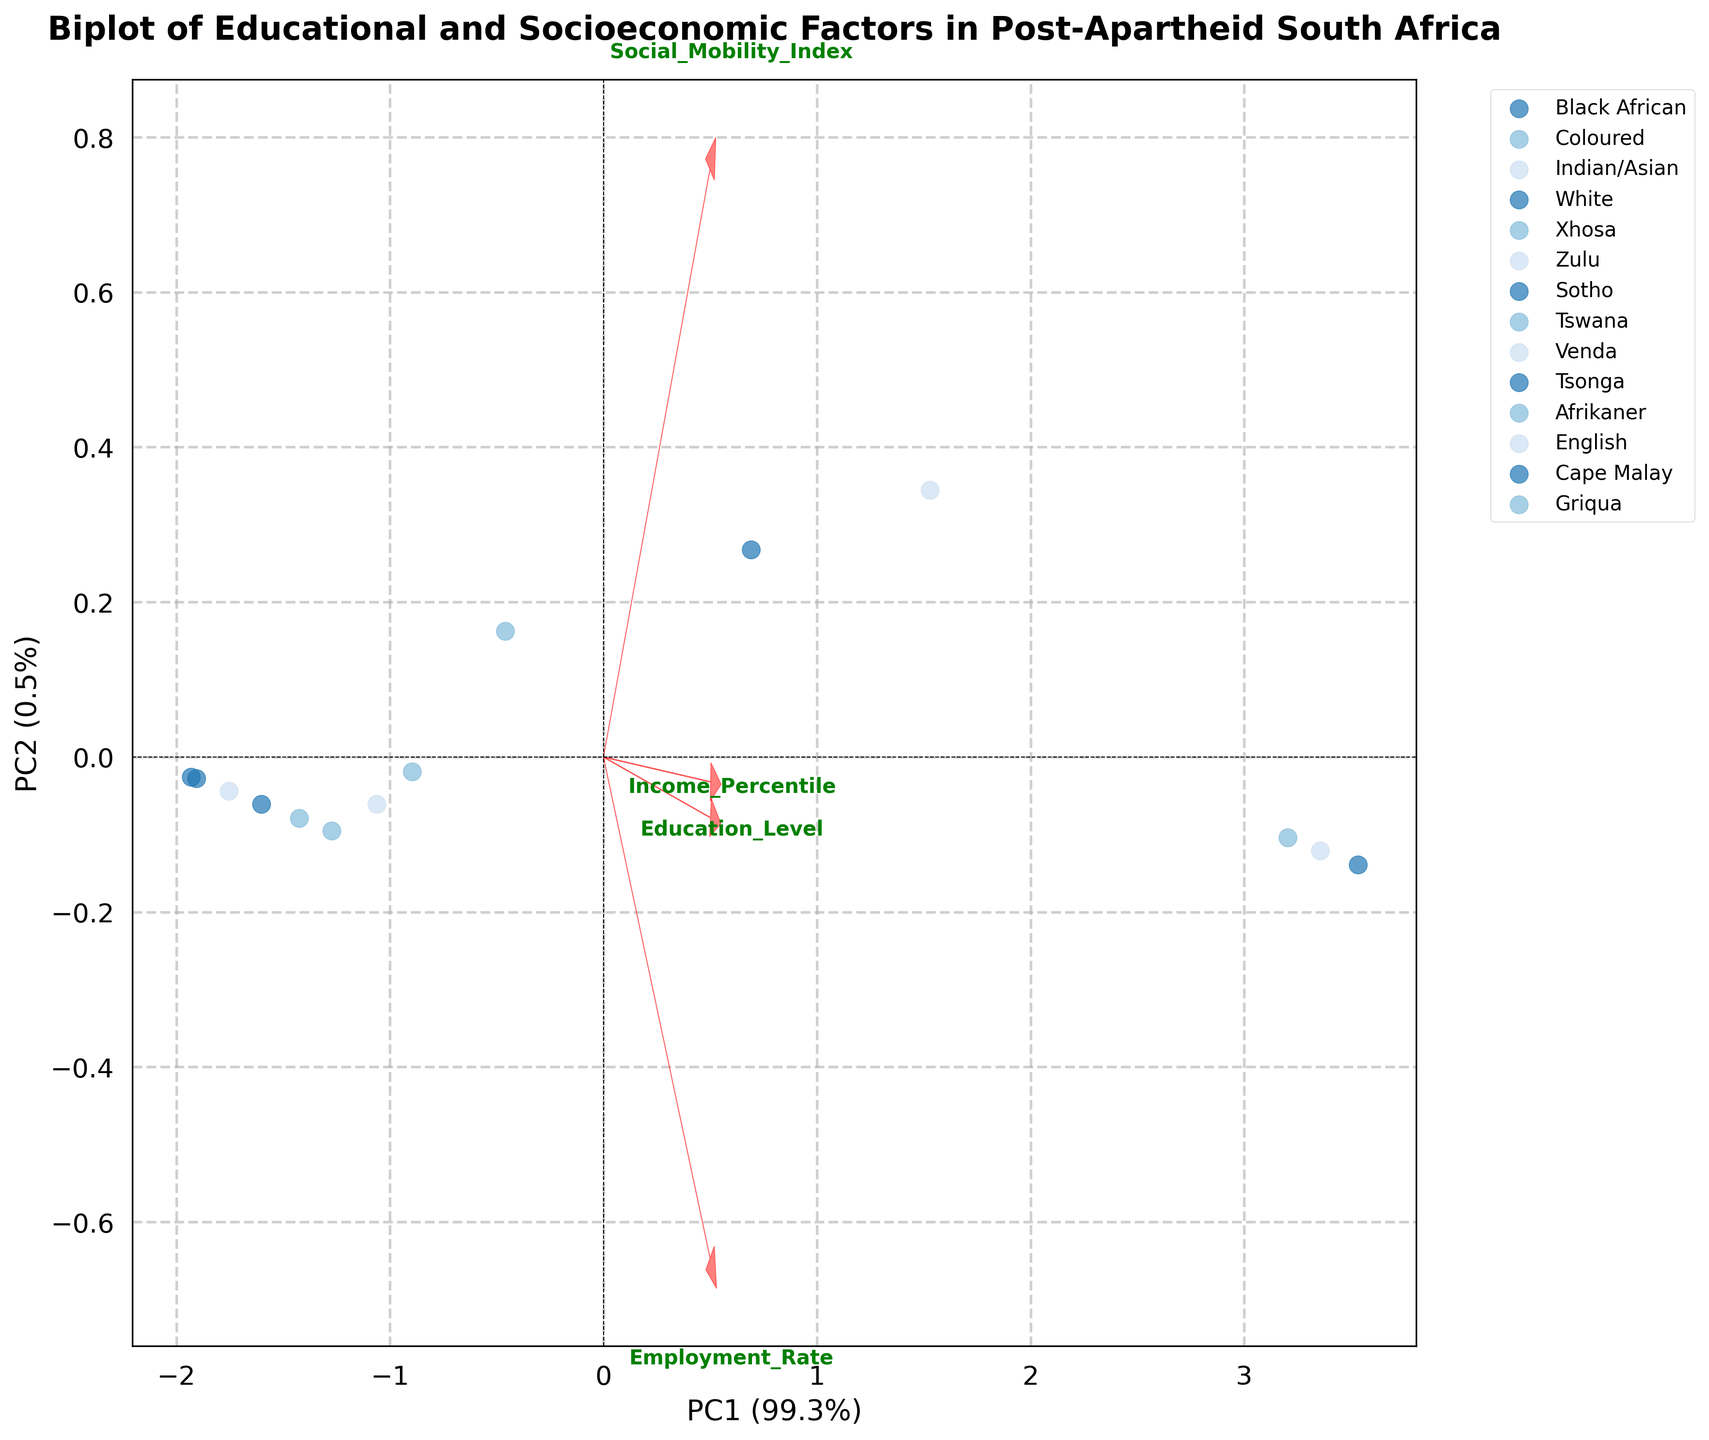What is the title of the figure? The title of the figure can be found at the top and it usually describes the main idea of the plot. In this case, it reads 'Biplot of Educational and Socioeconomic Factors in Post-Apartheid South Africa'.
Answer: Biplot of Educational and Socioeconomic Factors in Post-Apartheid South Africa How many ethnic groups are represented in the figure? To find the number of ethnic groups, count the unique labels in the legend of the plot. Each label represents a different ethnic group.
Answer: 14 Which axis represents the first principal component? Axes representing principal components have labels. The axis labeled 'PC1' represents the first principal component.
Answer: X-axis What does the second principal component explain in terms of variance? The amount of variance explained by a principal component is shown in parentheses on its axis label. For PC2, it is shown as a percentage of the total variance.
Answer: 27.1% Which group has the highest educational attainment? The plot uses points to denote groups and their principal component scores, and arrows to denote the principal components of the original features. Find the group closest to the arrow labeled 'Education_Level'.
Answer: White What is the relationship between education level and income percentile based on PC1? Observe the directions of the arrows for 'Education_Level' and 'Income_Percentile' relative to PC1. Both arrows point in the same direction along the PC1 axis, indicating they are positively correlated.
Answer: Positively correlated Which group shows the highest employment rate? Find the group closest to the arrow labeled 'Employment_Rate' as it points in the direction of high employment rate values.
Answer: White How does the social mobility index relate to employment rate and education level on PC2? Look at how the 'Social_Mobility_Index' arrow aligns with 'Employment_Rate' and 'Education_Level' along PC2. Notice whether they point in similar or opposing directions.
Answer: Positively correlated What can you infer about the group labeled 'Black African' based on the biplot's principal components? Locate 'Black African' and note its positions relative to the arrows for all original features. This group is positioned lower along PC1 and closer to the origin, indicating lower values in educational attainment, employment rate, income percentile, and social mobility index.
Answer: Lower values in all observed factors 